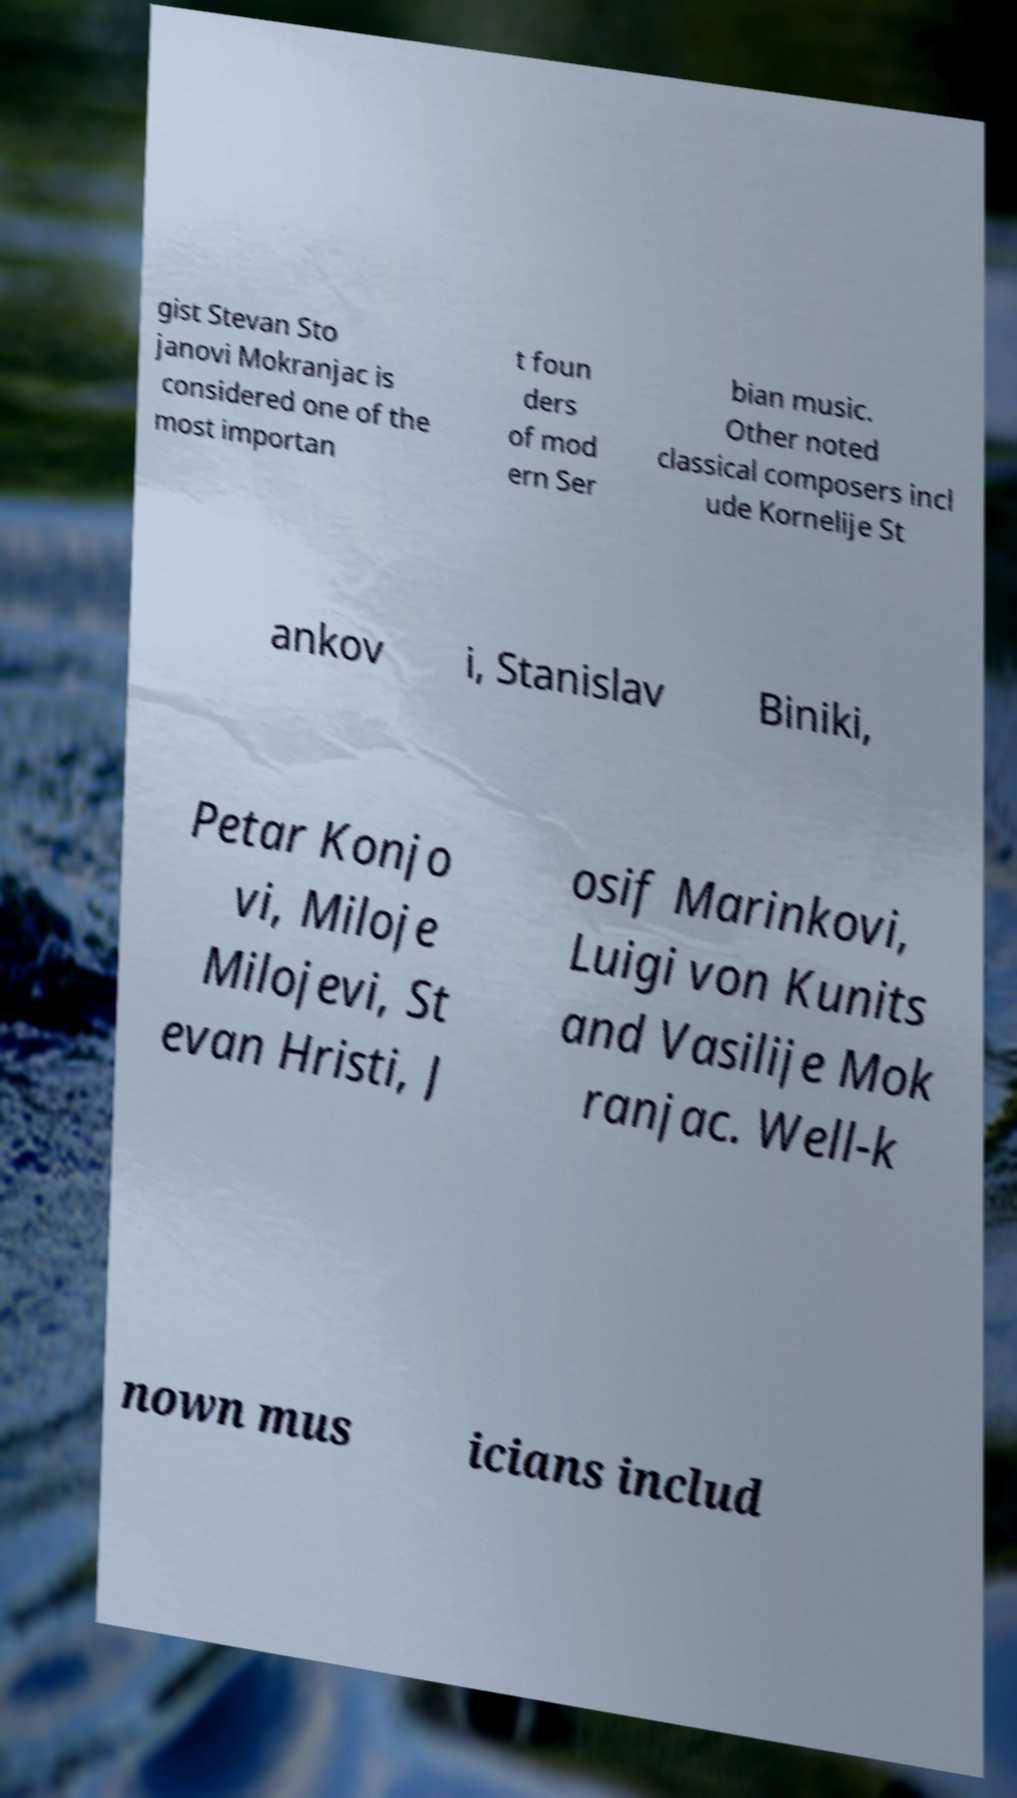For documentation purposes, I need the text within this image transcribed. Could you provide that? gist Stevan Sto janovi Mokranjac is considered one of the most importan t foun ders of mod ern Ser bian music. Other noted classical composers incl ude Kornelije St ankov i, Stanislav Biniki, Petar Konjo vi, Miloje Milojevi, St evan Hristi, J osif Marinkovi, Luigi von Kunits and Vasilije Mok ranjac. Well-k nown mus icians includ 